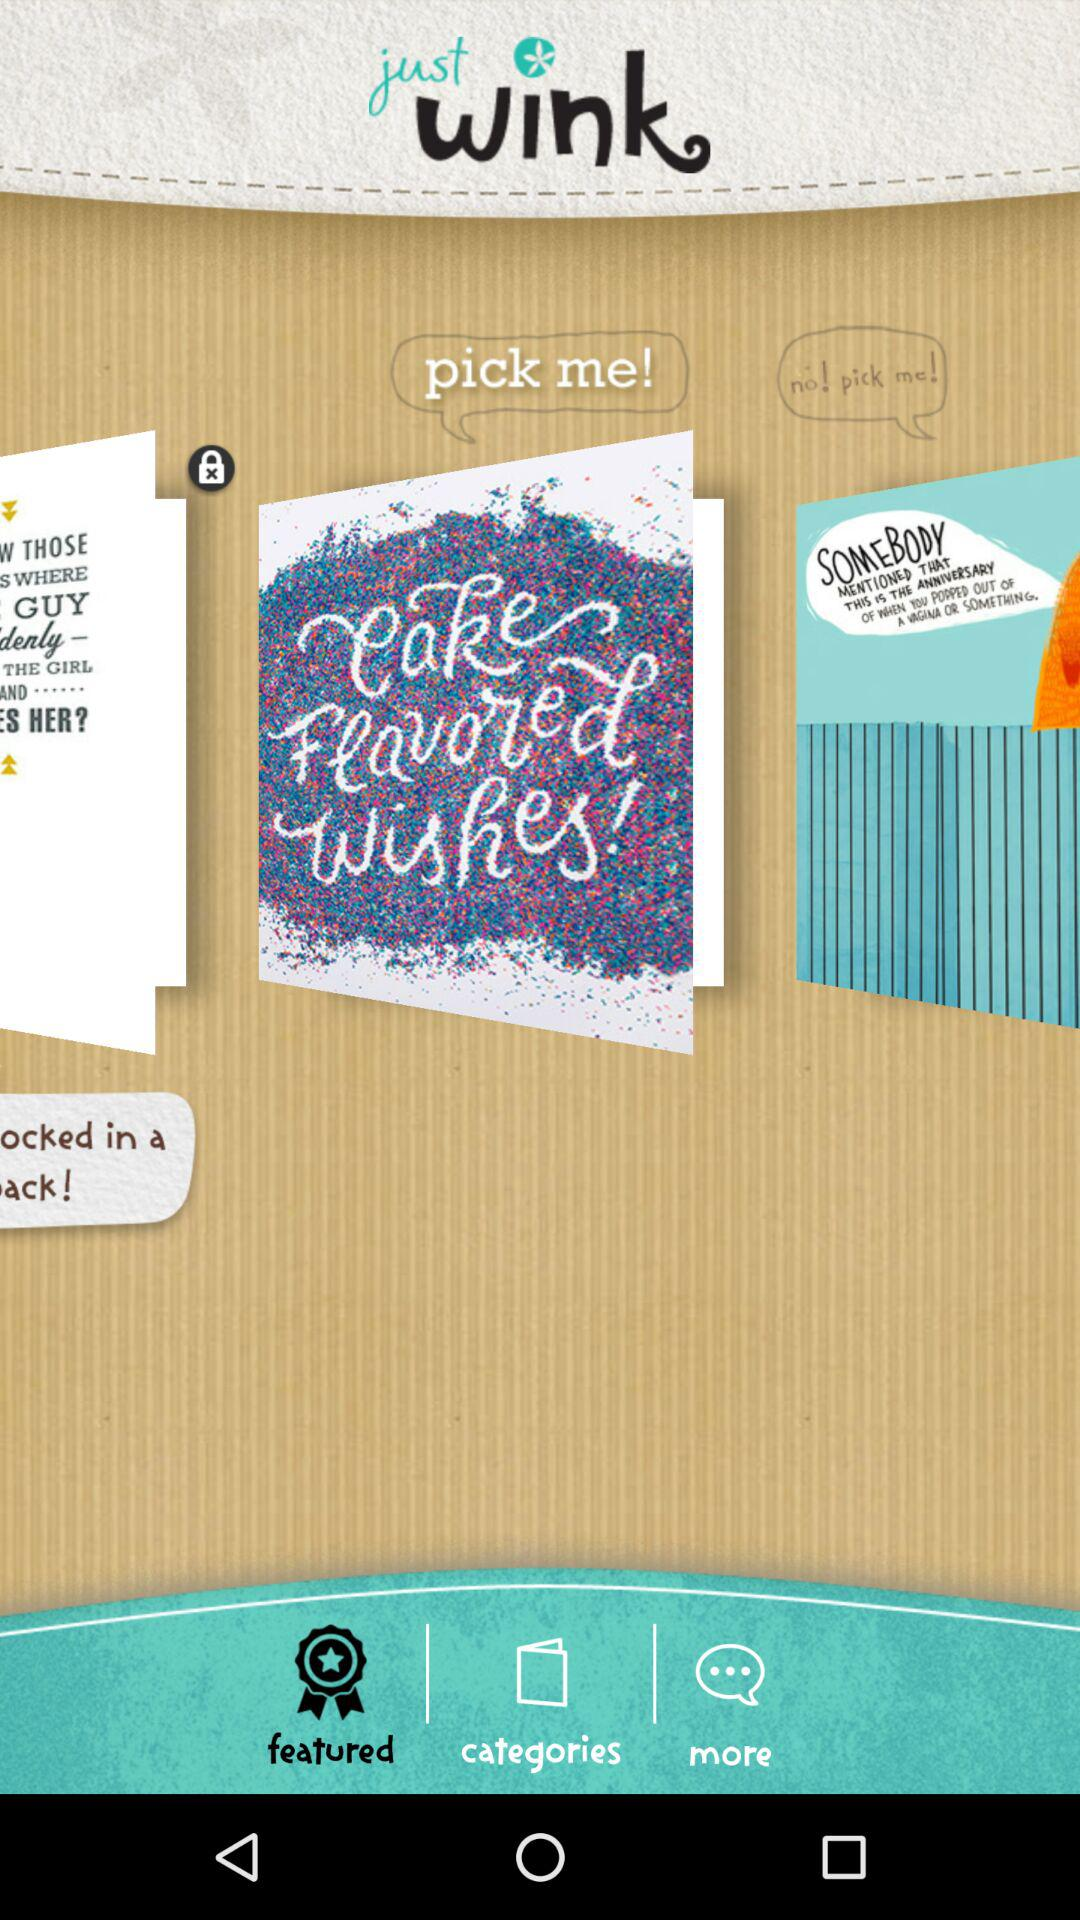What is the name of the application? The name of the application is "just wink". 